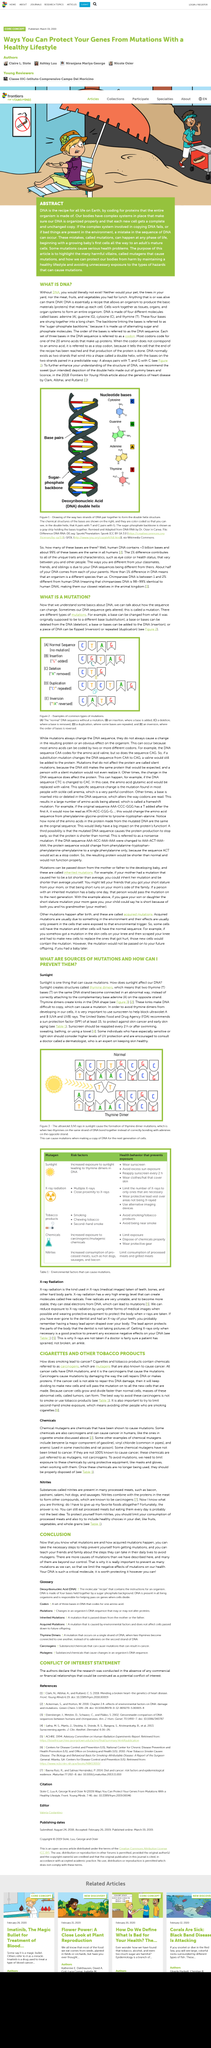Identify some key points in this picture. DNA is a recipe that provides the instructions for an organism to create proteins that make up cells. Mutations in DNA may alter the sequence, but they do not always result in a change in the resulting protein or a noticeable impact on the organism. Free radicals, in order to become more stable, can steal electrons from DNA. Exposure to sunlight has been linked to the formation of thymine dimers in DNA, posing a potential risk factor for skin cancer and other health issues. A sunscreen is used to block ultraviolet A and B rays, which are the harmful light rays that can cause skin damage and sunburn. 